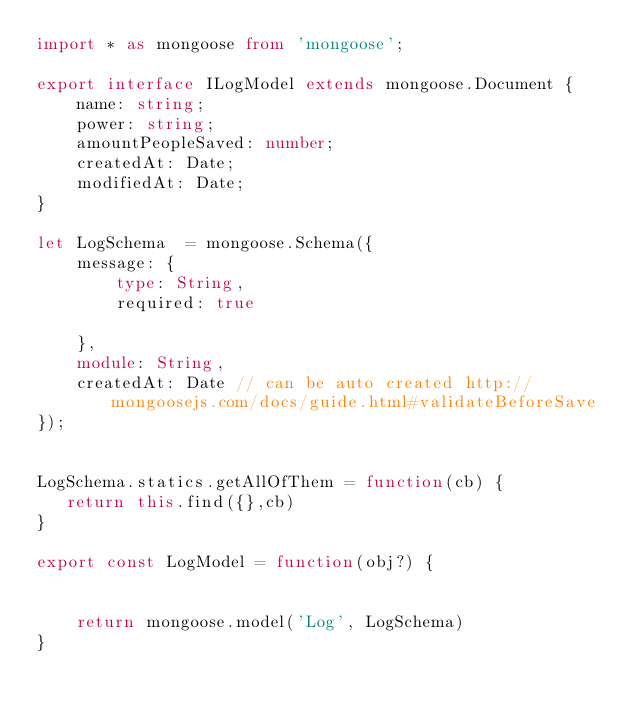<code> <loc_0><loc_0><loc_500><loc_500><_TypeScript_>import * as mongoose from 'mongoose';

export interface ILogModel extends mongoose.Document {
    name: string;
    power: string;
    amountPeopleSaved: number;
    createdAt: Date;
    modifiedAt: Date;
}

let LogSchema  = mongoose.Schema({
    message: {
        type: String,
        required: true

    },
    module: String,
    createdAt: Date // can be auto created http://mongoosejs.com/docs/guide.html#validateBeforeSave
});


LogSchema.statics.getAllOfThem = function(cb) {
   return this.find({},cb)
}

export const LogModel = function(obj?) {


    return mongoose.model('Log', LogSchema)
}

</code> 